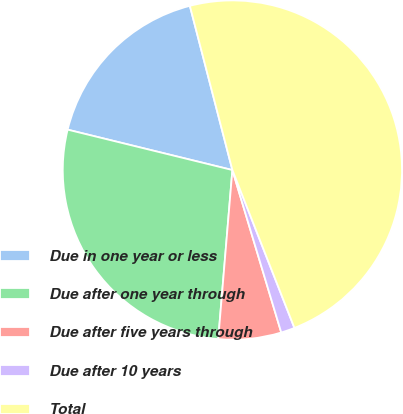Convert chart. <chart><loc_0><loc_0><loc_500><loc_500><pie_chart><fcel>Due in one year or less<fcel>Due after one year through<fcel>Due after five years through<fcel>Due after 10 years<fcel>Total<nl><fcel>17.14%<fcel>27.5%<fcel>5.98%<fcel>1.31%<fcel>48.08%<nl></chart> 